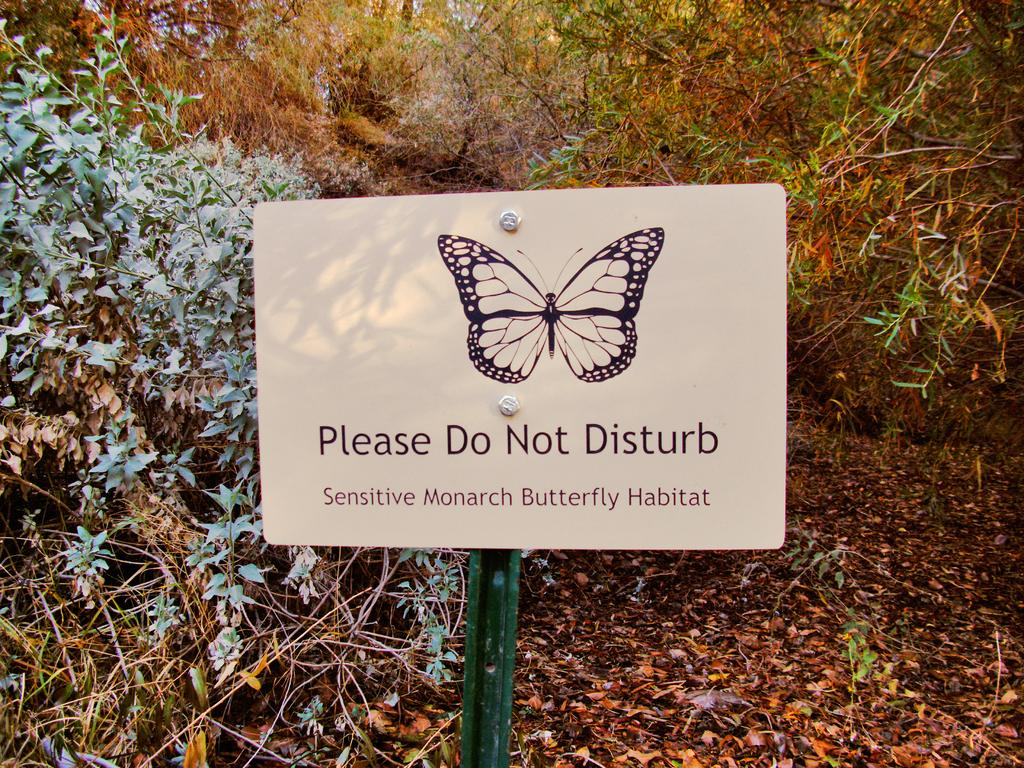What is attached to the pole in the image? There is a board attached to a pole in the image. What type of natural elements can be seen in the image? There are trees and plants in the image. What is present on the ground in the image? Dried leaves are lying on the ground in the image. What type of rhythm can be heard coming from the umbrella in the image? There is no umbrella present in the image, and therefore no rhythm can be heard. 